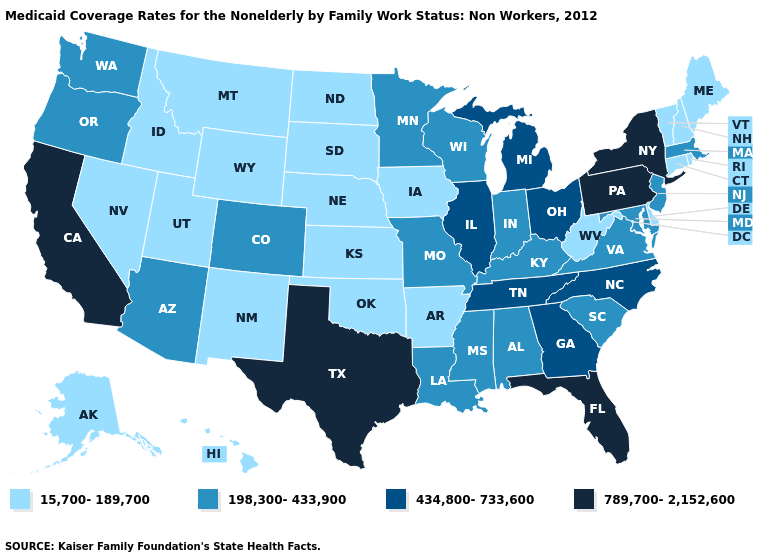What is the value of Missouri?
Short answer required. 198,300-433,900. Name the states that have a value in the range 15,700-189,700?
Quick response, please. Alaska, Arkansas, Connecticut, Delaware, Hawaii, Idaho, Iowa, Kansas, Maine, Montana, Nebraska, Nevada, New Hampshire, New Mexico, North Dakota, Oklahoma, Rhode Island, South Dakota, Utah, Vermont, West Virginia, Wyoming. What is the value of Kentucky?
Give a very brief answer. 198,300-433,900. Among the states that border Missouri , does Arkansas have the lowest value?
Write a very short answer. Yes. Name the states that have a value in the range 198,300-433,900?
Give a very brief answer. Alabama, Arizona, Colorado, Indiana, Kentucky, Louisiana, Maryland, Massachusetts, Minnesota, Mississippi, Missouri, New Jersey, Oregon, South Carolina, Virginia, Washington, Wisconsin. Does the map have missing data?
Keep it brief. No. Which states have the lowest value in the USA?
Answer briefly. Alaska, Arkansas, Connecticut, Delaware, Hawaii, Idaho, Iowa, Kansas, Maine, Montana, Nebraska, Nevada, New Hampshire, New Mexico, North Dakota, Oklahoma, Rhode Island, South Dakota, Utah, Vermont, West Virginia, Wyoming. What is the lowest value in the South?
Be succinct. 15,700-189,700. Name the states that have a value in the range 434,800-733,600?
Quick response, please. Georgia, Illinois, Michigan, North Carolina, Ohio, Tennessee. Name the states that have a value in the range 789,700-2,152,600?
Keep it brief. California, Florida, New York, Pennsylvania, Texas. What is the highest value in the West ?
Give a very brief answer. 789,700-2,152,600. Name the states that have a value in the range 198,300-433,900?
Give a very brief answer. Alabama, Arizona, Colorado, Indiana, Kentucky, Louisiana, Maryland, Massachusetts, Minnesota, Mississippi, Missouri, New Jersey, Oregon, South Carolina, Virginia, Washington, Wisconsin. What is the value of Wisconsin?
Be succinct. 198,300-433,900. What is the value of Michigan?
Quick response, please. 434,800-733,600. How many symbols are there in the legend?
Concise answer only. 4. 